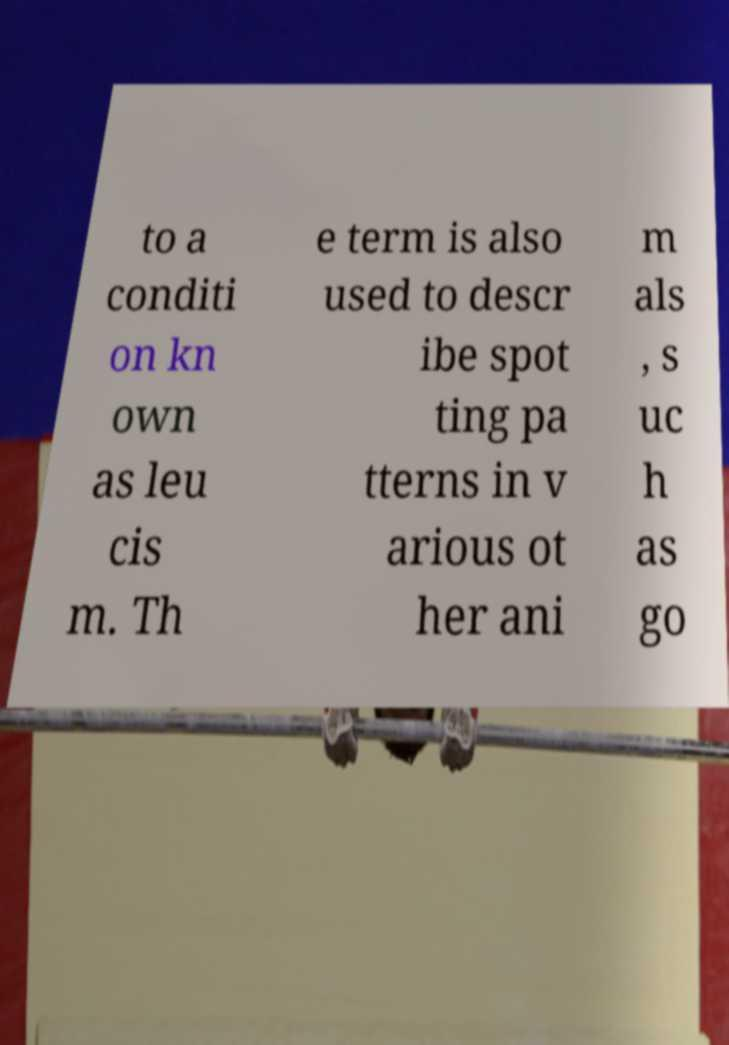There's text embedded in this image that I need extracted. Can you transcribe it verbatim? to a conditi on kn own as leu cis m. Th e term is also used to descr ibe spot ting pa tterns in v arious ot her ani m als , s uc h as go 